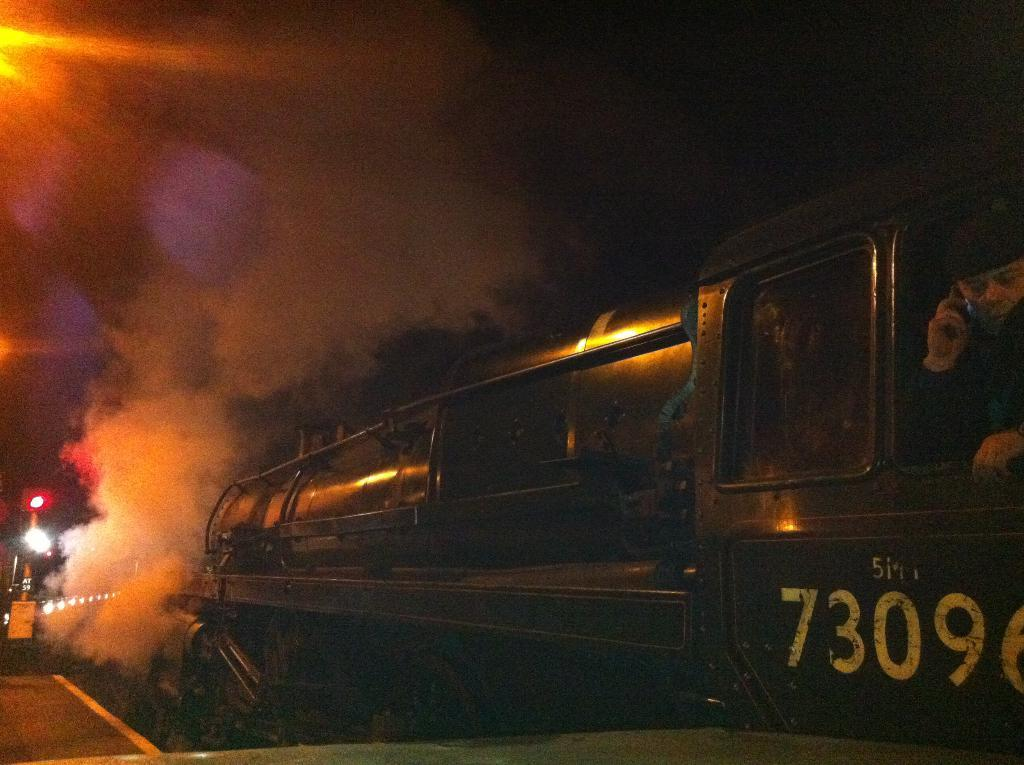What type of vehicle is in the image? There is a steam engine train in the image. Where is the train located? The train is on a railway track. What is the condition of the sky in the image? The sky is dark in the image. What type of cub can be seen playing with the judge in the image? There is no cub or judge present in the image; it features a steam engine train on a railway track with a dark sky. 